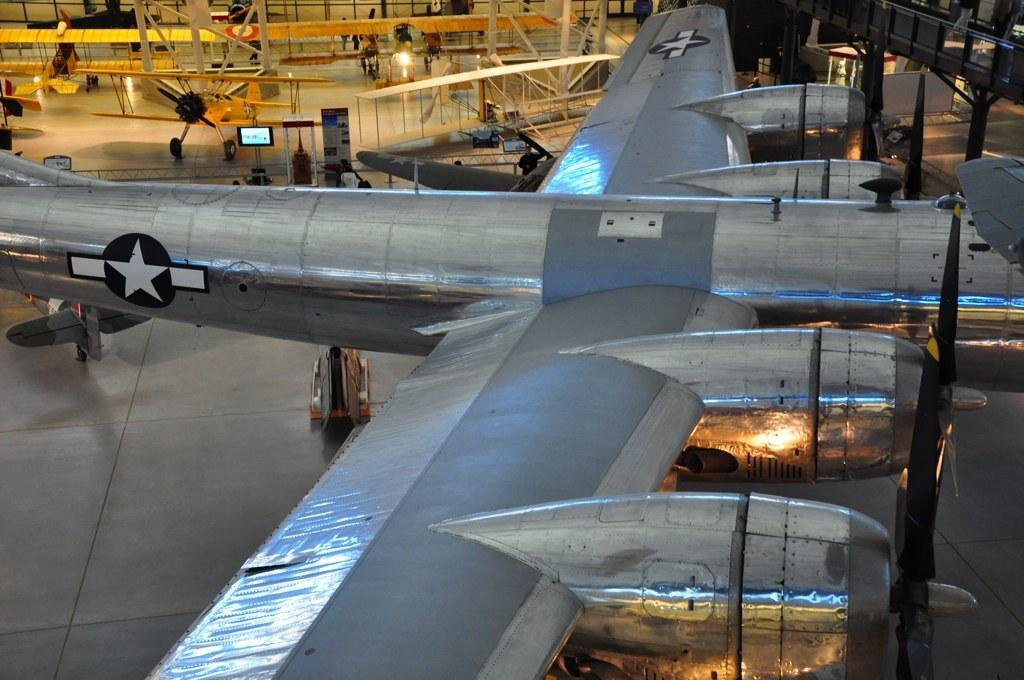What is on the surface in the image? There is a plan on the surface in the image. What can be seen in the background of the image? There are planes visible in the background of the image. Are there any people present in the image? Yes, there are people present in the image. How comfortable are the chairs in the image? There is no mention of chairs in the image, so it is not possible to determine their comfort level. 